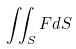Convert formula to latex. <formula><loc_0><loc_0><loc_500><loc_500>\iint _ { S } F d S</formula> 